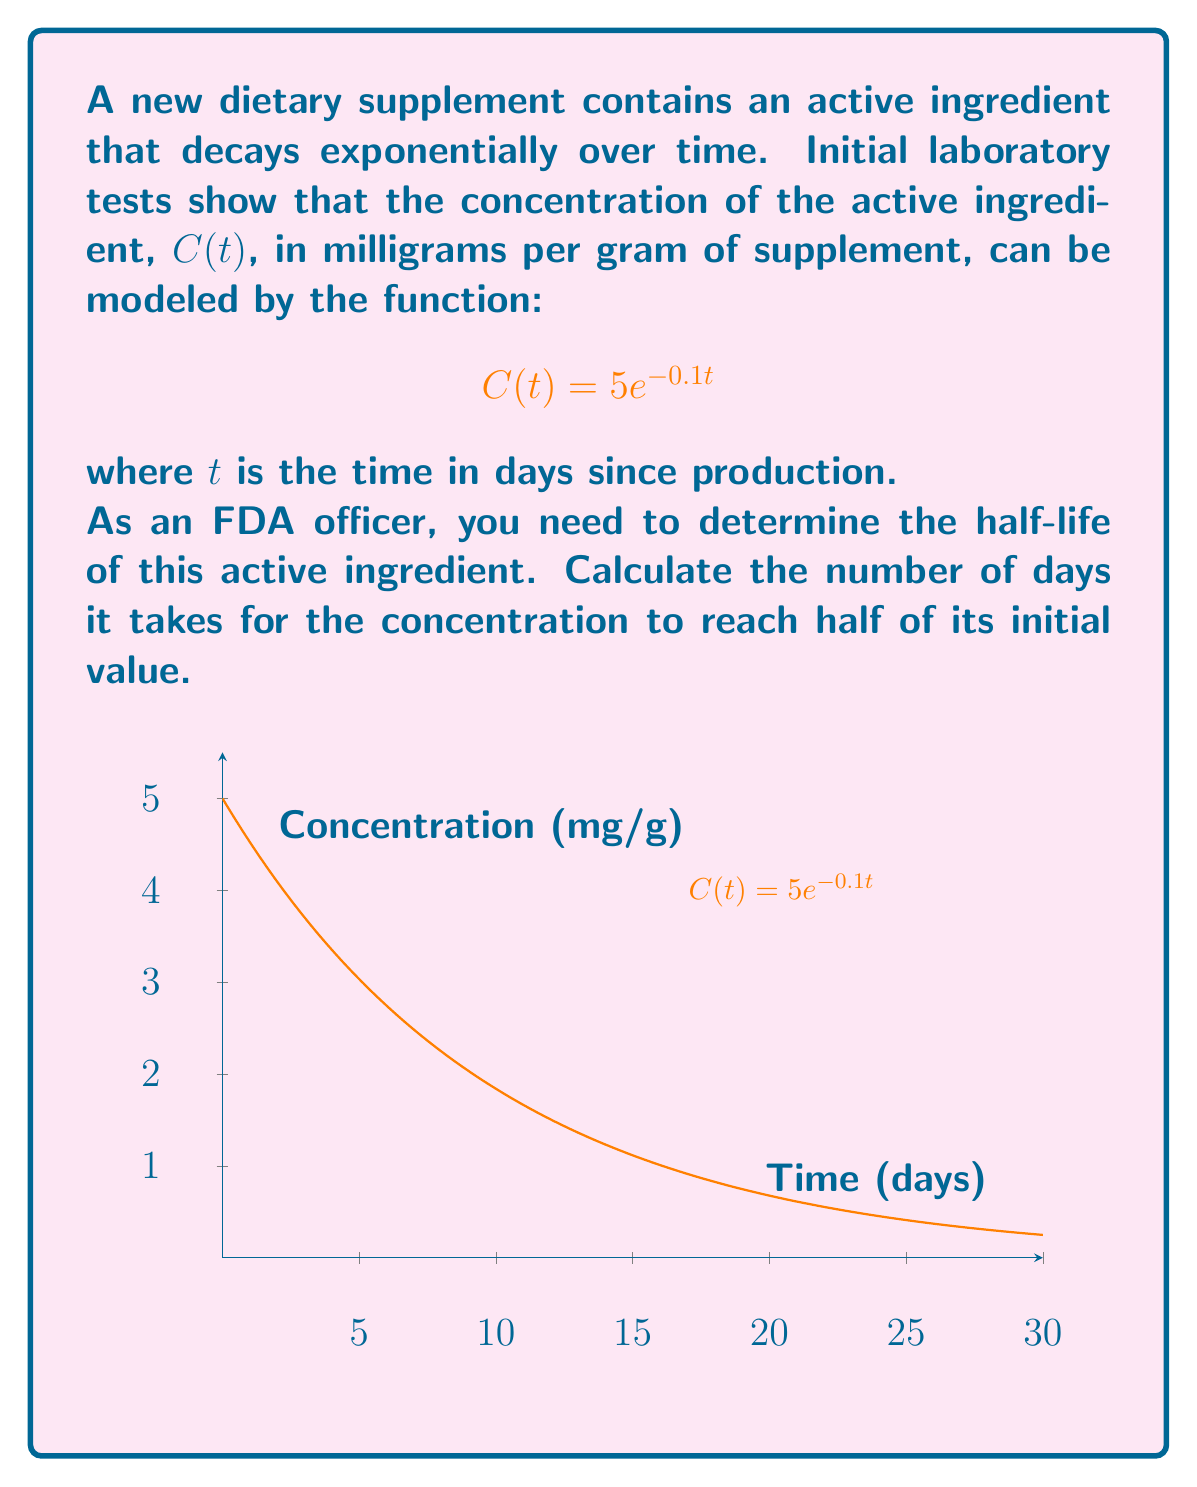What is the answer to this math problem? To solve this problem, we'll follow these steps:

1) The half-life is the time it takes for the concentration to reach half of its initial value. Let's call this time $t_{1/2}$.

2) The initial concentration (at $t=0$) is:
   $$C(0) = 5e^{-0.1(0)} = 5$$ mg/g

3) At the half-life, the concentration will be half of this:
   $$C(t_{1/2}) = \frac{5}{2} = 2.5$$ mg/g

4) We can set up an equation:
   $$5e^{-0.1t_{1/2}} = 2.5$$

5) Divide both sides by 5:
   $$e^{-0.1t_{1/2}} = \frac{1}{2}$$

6) Take the natural logarithm of both sides:
   $$-0.1t_{1/2} = \ln(\frac{1}{2}) = -\ln(2)$$

7) Solve for $t_{1/2}$:
   $$t_{1/2} = \frac{\ln(2)}{0.1} \approx 6.93$$ days

Therefore, it takes approximately 6.93 days for the concentration of the active ingredient to reach half of its initial value.
Answer: 6.93 days 